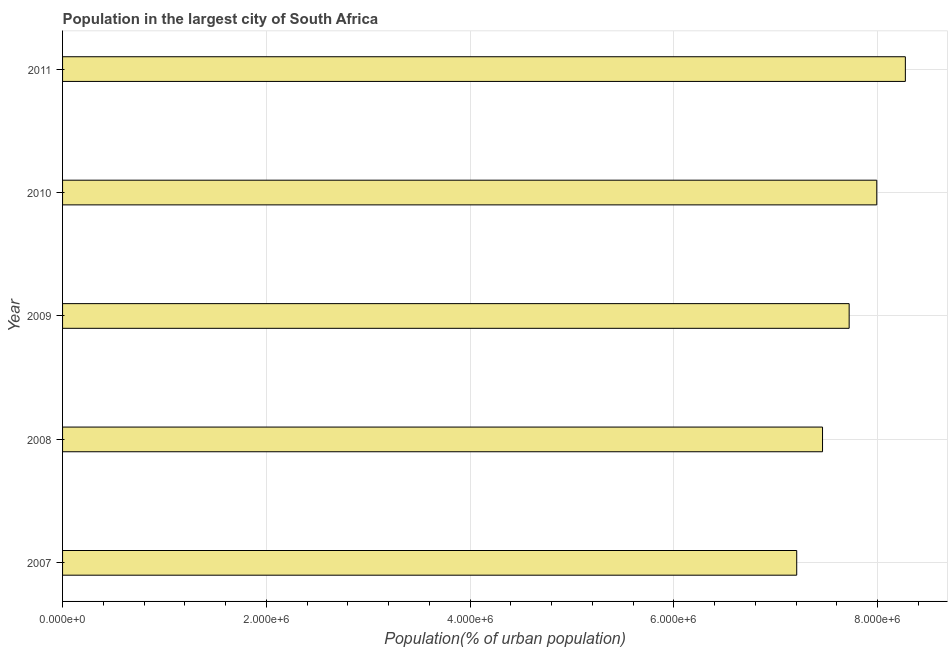What is the title of the graph?
Offer a very short reply. Population in the largest city of South Africa. What is the label or title of the X-axis?
Ensure brevity in your answer.  Population(% of urban population). What is the label or title of the Y-axis?
Keep it short and to the point. Year. What is the population in largest city in 2008?
Provide a short and direct response. 7.46e+06. Across all years, what is the maximum population in largest city?
Your response must be concise. 8.27e+06. Across all years, what is the minimum population in largest city?
Keep it short and to the point. 7.21e+06. In which year was the population in largest city maximum?
Offer a very short reply. 2011. In which year was the population in largest city minimum?
Keep it short and to the point. 2007. What is the sum of the population in largest city?
Your answer should be compact. 3.87e+07. What is the difference between the population in largest city in 2008 and 2011?
Provide a short and direct response. -8.13e+05. What is the average population in largest city per year?
Ensure brevity in your answer.  7.73e+06. What is the median population in largest city?
Provide a short and direct response. 7.72e+06. Do a majority of the years between 2008 and 2009 (inclusive) have population in largest city greater than 6800000 %?
Offer a terse response. Yes. What is the ratio of the population in largest city in 2009 to that in 2011?
Keep it short and to the point. 0.93. Is the population in largest city in 2007 less than that in 2009?
Make the answer very short. Yes. Is the difference between the population in largest city in 2008 and 2010 greater than the difference between any two years?
Your response must be concise. No. What is the difference between the highest and the second highest population in largest city?
Your answer should be compact. 2.81e+05. Is the sum of the population in largest city in 2007 and 2009 greater than the maximum population in largest city across all years?
Your answer should be compact. Yes. What is the difference between the highest and the lowest population in largest city?
Ensure brevity in your answer.  1.07e+06. In how many years, is the population in largest city greater than the average population in largest city taken over all years?
Provide a short and direct response. 2. How many bars are there?
Give a very brief answer. 5. Are all the bars in the graph horizontal?
Offer a very short reply. Yes. How many years are there in the graph?
Your answer should be compact. 5. Are the values on the major ticks of X-axis written in scientific E-notation?
Keep it short and to the point. Yes. What is the Population(% of urban population) in 2007?
Offer a very short reply. 7.21e+06. What is the Population(% of urban population) of 2008?
Ensure brevity in your answer.  7.46e+06. What is the Population(% of urban population) in 2009?
Ensure brevity in your answer.  7.72e+06. What is the Population(% of urban population) of 2010?
Keep it short and to the point. 7.99e+06. What is the Population(% of urban population) in 2011?
Your answer should be very brief. 8.27e+06. What is the difference between the Population(% of urban population) in 2007 and 2008?
Your answer should be very brief. -2.53e+05. What is the difference between the Population(% of urban population) in 2007 and 2009?
Keep it short and to the point. -5.15e+05. What is the difference between the Population(% of urban population) in 2007 and 2010?
Make the answer very short. -7.86e+05. What is the difference between the Population(% of urban population) in 2007 and 2011?
Your response must be concise. -1.07e+06. What is the difference between the Population(% of urban population) in 2008 and 2009?
Ensure brevity in your answer.  -2.61e+05. What is the difference between the Population(% of urban population) in 2008 and 2010?
Your answer should be compact. -5.32e+05. What is the difference between the Population(% of urban population) in 2008 and 2011?
Ensure brevity in your answer.  -8.13e+05. What is the difference between the Population(% of urban population) in 2009 and 2010?
Provide a succinct answer. -2.71e+05. What is the difference between the Population(% of urban population) in 2009 and 2011?
Provide a short and direct response. -5.52e+05. What is the difference between the Population(% of urban population) in 2010 and 2011?
Provide a short and direct response. -2.81e+05. What is the ratio of the Population(% of urban population) in 2007 to that in 2009?
Make the answer very short. 0.93. What is the ratio of the Population(% of urban population) in 2007 to that in 2010?
Keep it short and to the point. 0.9. What is the ratio of the Population(% of urban population) in 2007 to that in 2011?
Ensure brevity in your answer.  0.87. What is the ratio of the Population(% of urban population) in 2008 to that in 2009?
Give a very brief answer. 0.97. What is the ratio of the Population(% of urban population) in 2008 to that in 2010?
Your answer should be very brief. 0.93. What is the ratio of the Population(% of urban population) in 2008 to that in 2011?
Give a very brief answer. 0.9. What is the ratio of the Population(% of urban population) in 2009 to that in 2010?
Ensure brevity in your answer.  0.97. What is the ratio of the Population(% of urban population) in 2009 to that in 2011?
Give a very brief answer. 0.93. What is the ratio of the Population(% of urban population) in 2010 to that in 2011?
Provide a succinct answer. 0.97. 